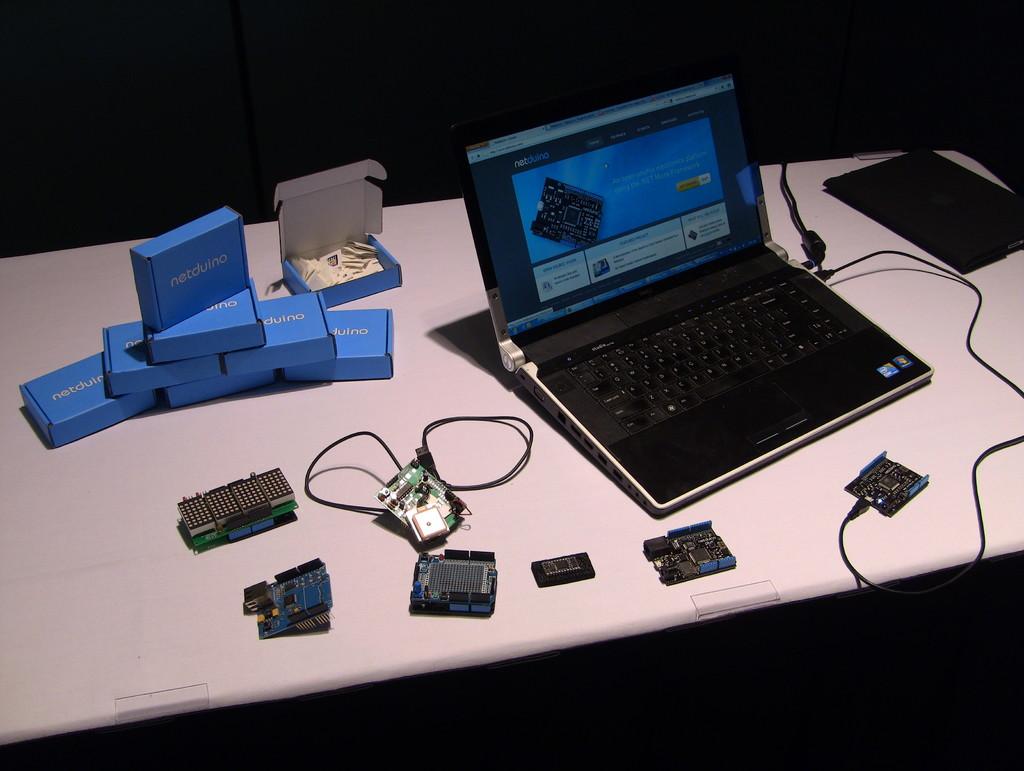What brand are the blue boxes?
Provide a short and direct response. Netduino. What is the brand of the laptop?
Offer a very short reply. Unanswerable. 